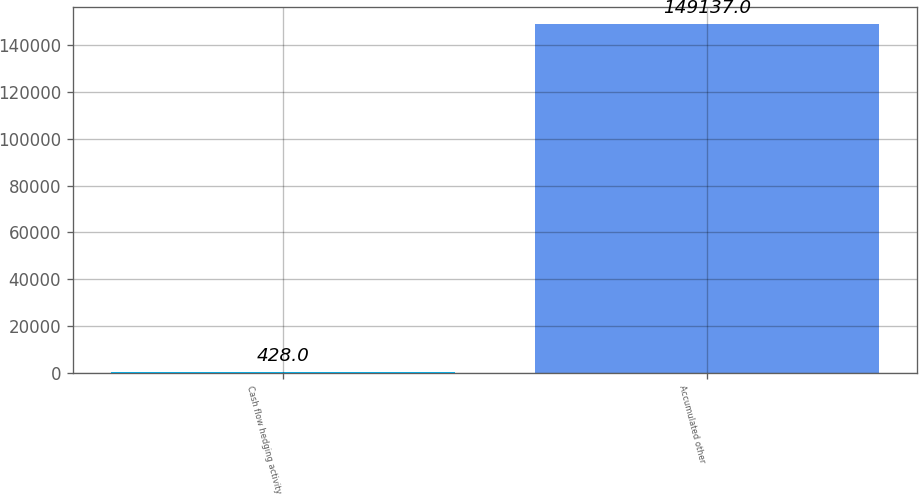<chart> <loc_0><loc_0><loc_500><loc_500><bar_chart><fcel>Cash flow hedging activity<fcel>Accumulated other<nl><fcel>428<fcel>149137<nl></chart> 